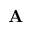Convert formula to latex. <formula><loc_0><loc_0><loc_500><loc_500>A</formula> 